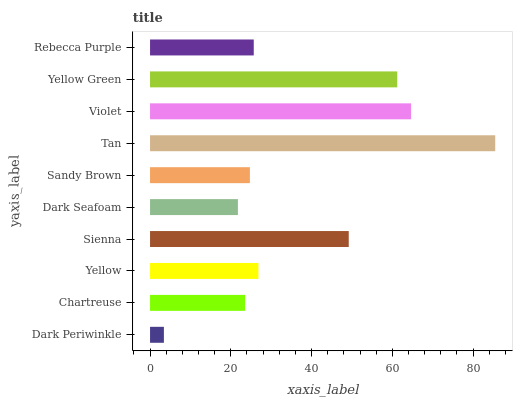Is Dark Periwinkle the minimum?
Answer yes or no. Yes. Is Tan the maximum?
Answer yes or no. Yes. Is Chartreuse the minimum?
Answer yes or no. No. Is Chartreuse the maximum?
Answer yes or no. No. Is Chartreuse greater than Dark Periwinkle?
Answer yes or no. Yes. Is Dark Periwinkle less than Chartreuse?
Answer yes or no. Yes. Is Dark Periwinkle greater than Chartreuse?
Answer yes or no. No. Is Chartreuse less than Dark Periwinkle?
Answer yes or no. No. Is Yellow the high median?
Answer yes or no. Yes. Is Rebecca Purple the low median?
Answer yes or no. Yes. Is Sandy Brown the high median?
Answer yes or no. No. Is Violet the low median?
Answer yes or no. No. 